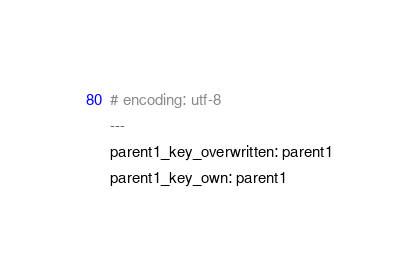<code> <loc_0><loc_0><loc_500><loc_500><_YAML_># encoding: utf-8
---
parent1_key_overwritten: parent1
parent1_key_own: parent1</code> 